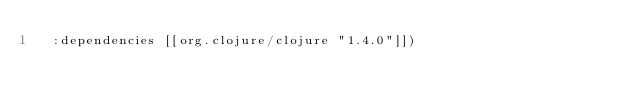Convert code to text. <code><loc_0><loc_0><loc_500><loc_500><_Clojure_>  :dependencies [[org.clojure/clojure "1.4.0"]])
</code> 